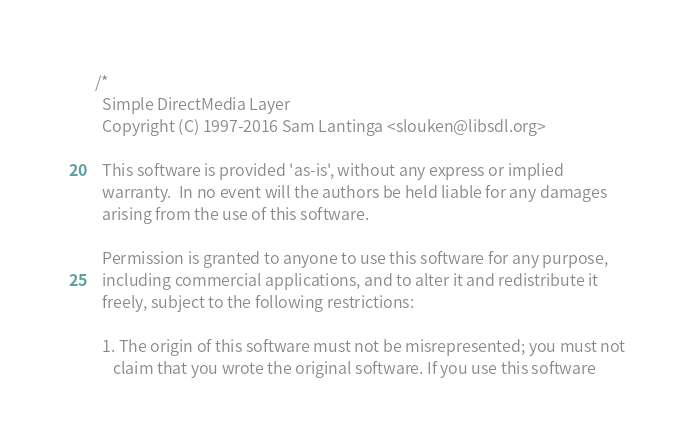<code> <loc_0><loc_0><loc_500><loc_500><_C_>/*
  Simple DirectMedia Layer
  Copyright (C) 1997-2016 Sam Lantinga <slouken@libsdl.org>

  This software is provided 'as-is', without any express or implied
  warranty.  In no event will the authors be held liable for any damages
  arising from the use of this software.

  Permission is granted to anyone to use this software for any purpose,
  including commercial applications, and to alter it and redistribute it
  freely, subject to the following restrictions:

  1. The origin of this software must not be misrepresented; you must not
     claim that you wrote the original software. If you use this software</code> 